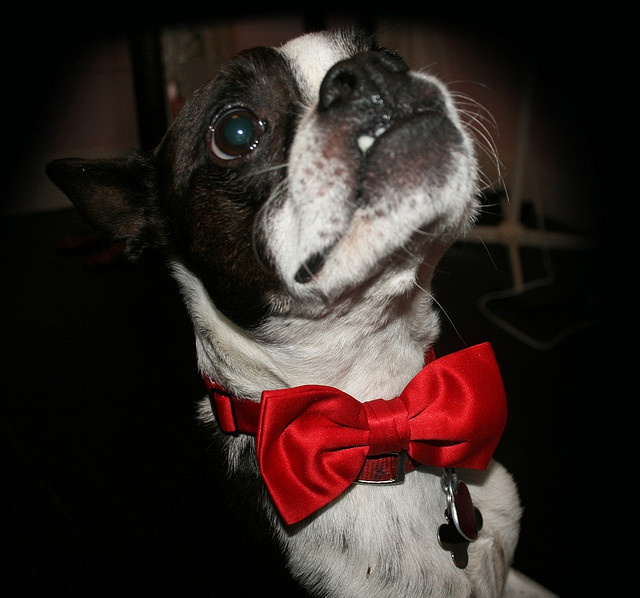Describe the objects in this image and their specific colors. I can see dog in black, darkgray, gray, and maroon tones and tie in black, brown, and maroon tones in this image. 